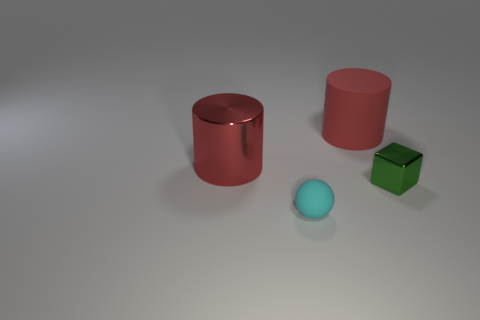Add 1 small blue shiny blocks. How many objects exist? 5 Subtract all cubes. How many objects are left? 3 Subtract all tiny cyan rubber objects. Subtract all tiny green shiny things. How many objects are left? 2 Add 1 tiny things. How many tiny things are left? 3 Add 4 tiny spheres. How many tiny spheres exist? 5 Subtract 0 brown cubes. How many objects are left? 4 